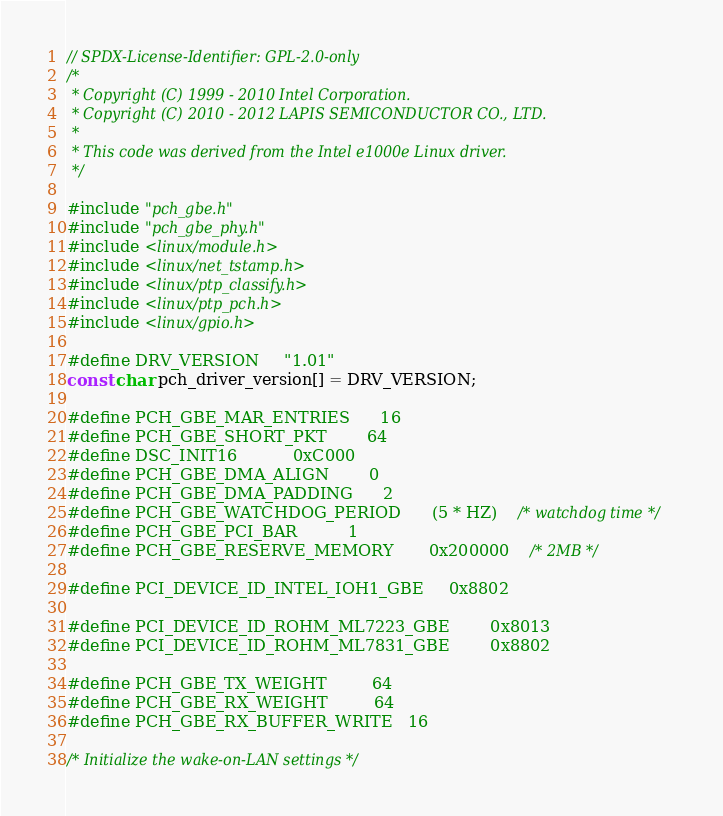Convert code to text. <code><loc_0><loc_0><loc_500><loc_500><_C_>// SPDX-License-Identifier: GPL-2.0-only
/*
 * Copyright (C) 1999 - 2010 Intel Corporation.
 * Copyright (C) 2010 - 2012 LAPIS SEMICONDUCTOR CO., LTD.
 *
 * This code was derived from the Intel e1000e Linux driver.
 */

#include "pch_gbe.h"
#include "pch_gbe_phy.h"
#include <linux/module.h>
#include <linux/net_tstamp.h>
#include <linux/ptp_classify.h>
#include <linux/ptp_pch.h>
#include <linux/gpio.h>

#define DRV_VERSION     "1.01"
const char pch_driver_version[] = DRV_VERSION;

#define PCH_GBE_MAR_ENTRIES		16
#define PCH_GBE_SHORT_PKT		64
#define DSC_INIT16			0xC000
#define PCH_GBE_DMA_ALIGN		0
#define PCH_GBE_DMA_PADDING		2
#define PCH_GBE_WATCHDOG_PERIOD		(5 * HZ)	/* watchdog time */
#define PCH_GBE_PCI_BAR			1
#define PCH_GBE_RESERVE_MEMORY		0x200000	/* 2MB */

#define PCI_DEVICE_ID_INTEL_IOH1_GBE		0x8802

#define PCI_DEVICE_ID_ROHM_ML7223_GBE		0x8013
#define PCI_DEVICE_ID_ROHM_ML7831_GBE		0x8802

#define PCH_GBE_TX_WEIGHT         64
#define PCH_GBE_RX_WEIGHT         64
#define PCH_GBE_RX_BUFFER_WRITE   16

/* Initialize the wake-on-LAN settings */</code> 